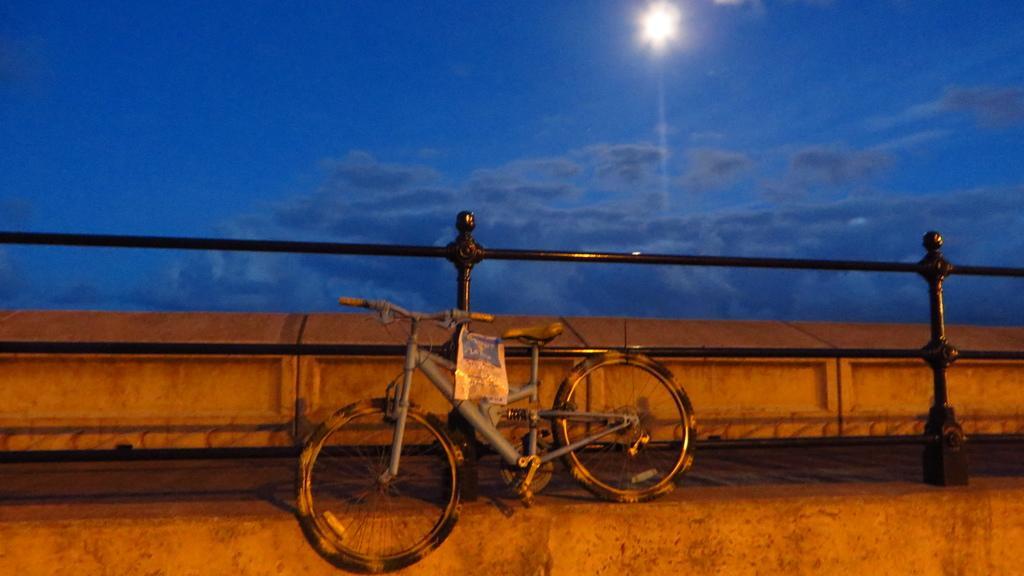Could you give a brief overview of what you see in this image? In this picture, we can see bicycle, and we can see poster, fencing, a path, and the sky with clouds, and moon. 